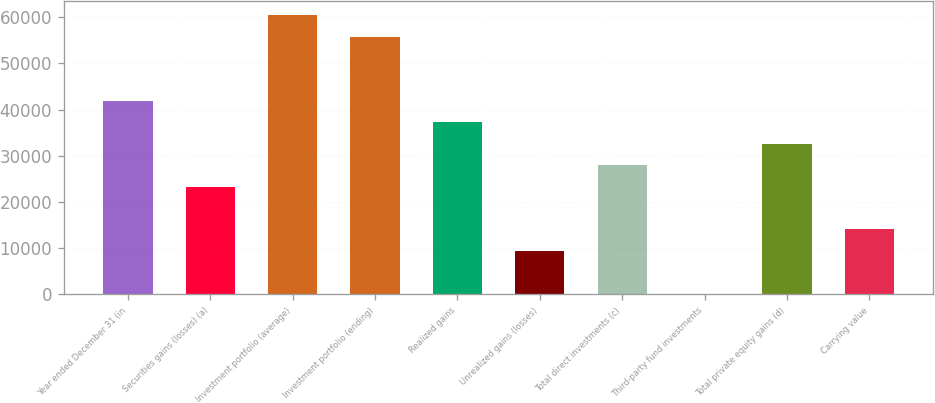Convert chart to OTSL. <chart><loc_0><loc_0><loc_500><loc_500><bar_chart><fcel>Year ended December 31 (in<fcel>Securities gains (losses) (a)<fcel>Investment portfolio (average)<fcel>Investment portfolio (ending)<fcel>Realized gains<fcel>Unrealized gains (losses)<fcel>Total direct investments (c)<fcel>Third-party fund investments<fcel>Total private equity gains (d)<fcel>Carrying value<nl><fcel>41881.2<fcel>23326<fcel>60436.4<fcel>55797.6<fcel>37242.4<fcel>9409.6<fcel>27964.8<fcel>132<fcel>32603.6<fcel>14048.4<nl></chart> 